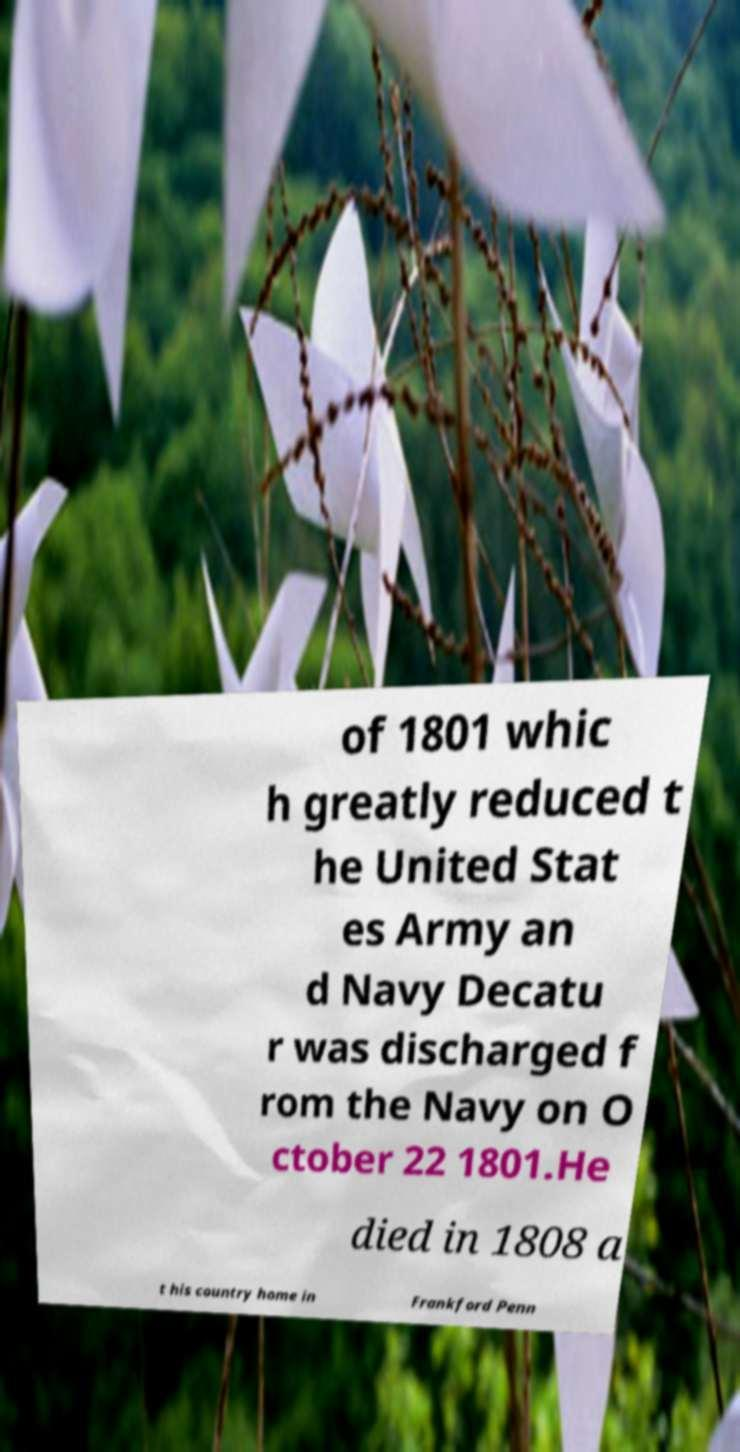There's text embedded in this image that I need extracted. Can you transcribe it verbatim? of 1801 whic h greatly reduced t he United Stat es Army an d Navy Decatu r was discharged f rom the Navy on O ctober 22 1801.He died in 1808 a t his country home in Frankford Penn 